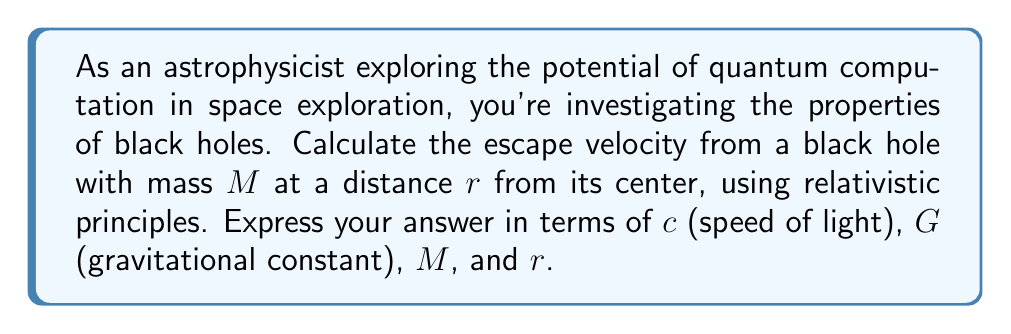Can you solve this math problem? To solve this problem, we need to use the principles of general relativity and the concept of the Schwarzschild radius. Let's approach this step-by-step:

1. The Schwarzschild radius ($r_s$) of a black hole is given by:

   $$r_s = \frac{2GM}{c^2}$$

   where $G$ is the gravitational constant, $M$ is the mass of the black hole, and $c$ is the speed of light.

2. In Newtonian mechanics, the escape velocity $v_e$ at a distance $r$ from the center of a massive object is given by:

   $$v_e = \sqrt{\frac{2GM}{r}}$$

3. However, for a black hole, we need to use relativistic principles. The relativistic formula for escape velocity is:

   $$v_e = c\sqrt{1 - \frac{r_s}{r}}$$

4. Substituting the expression for $r_s$ from step 1 into this equation:

   $$v_e = c\sqrt{1 - \frac{2GM}{rc^2}}$$

5. This equation gives us the escape velocity at any distance $r$ from the center of the black hole, in terms of $c$, $G$, $M$, and $r$.

6. Note that as $r$ approaches $r_s$, the escape velocity approaches $c$. For $r < r_s$, the equation yields imaginary values, which is consistent with the fact that nothing can escape from within the event horizon of a black hole.

This relativistic approach is crucial for understanding the behavior of matter and energy near black holes, which could be essential in future space exploration utilizing quantum computation techniques.
Answer: $$v_e = c\sqrt{1 - \frac{2GM}{rc^2}}$$ 